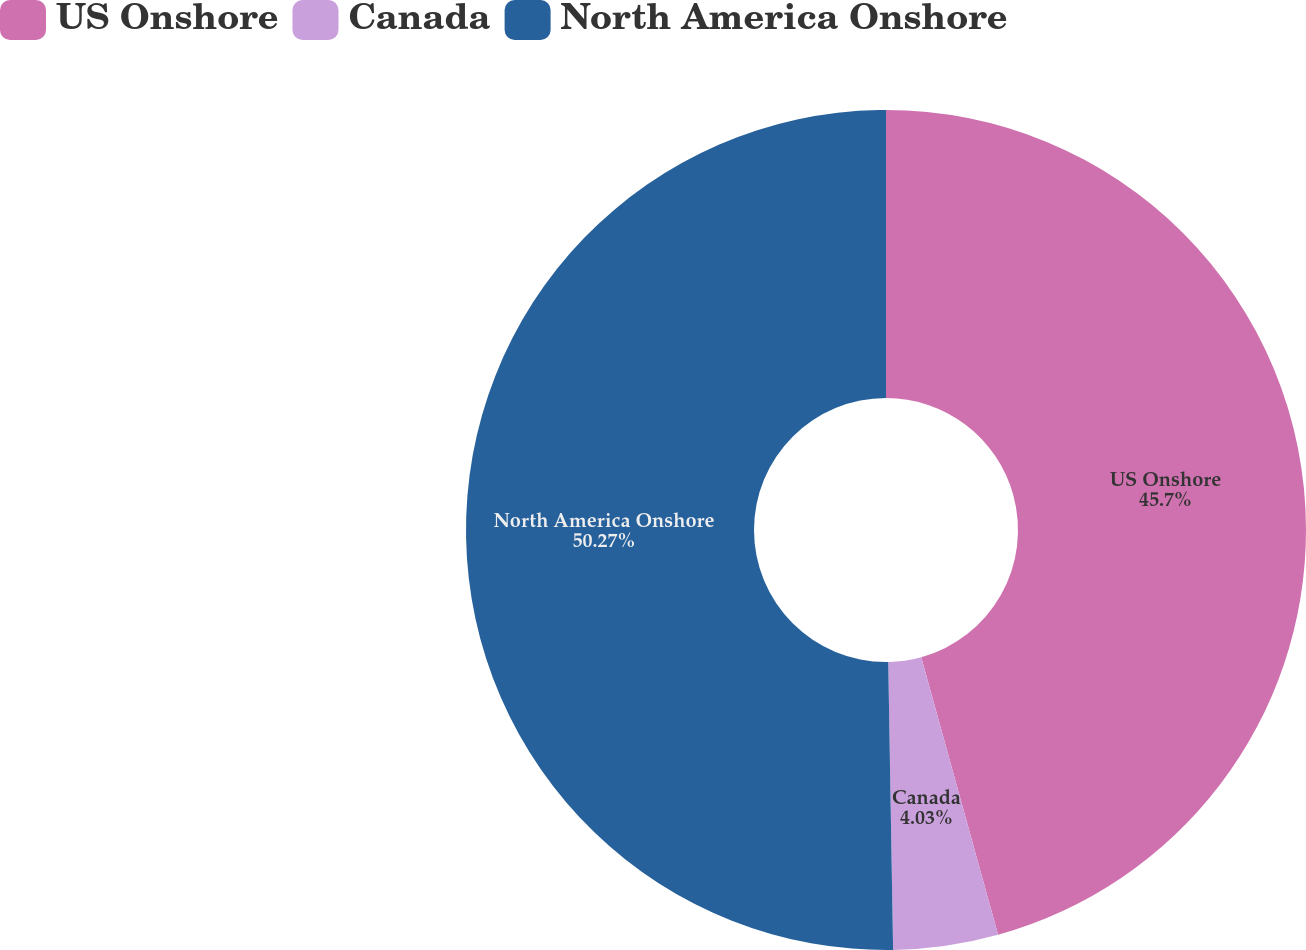Convert chart to OTSL. <chart><loc_0><loc_0><loc_500><loc_500><pie_chart><fcel>US Onshore<fcel>Canada<fcel>North America Onshore<nl><fcel>45.7%<fcel>4.03%<fcel>50.27%<nl></chart> 